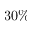Convert formula to latex. <formula><loc_0><loc_0><loc_500><loc_500>3 0 \%</formula> 